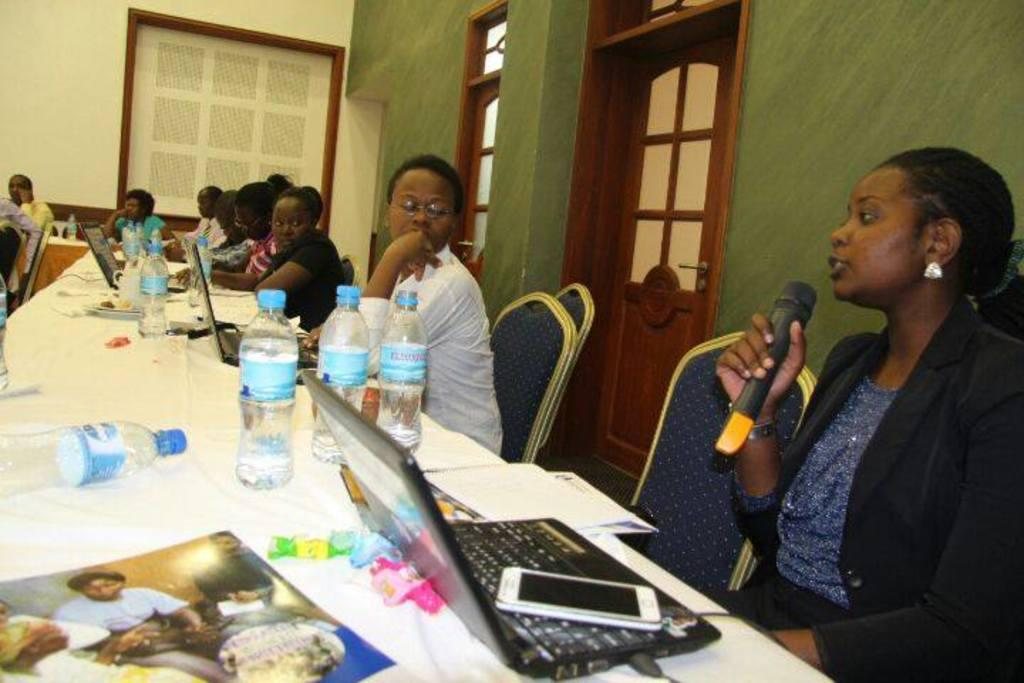How many people are in the room? There are people in the room, but the exact number is not specified. What are the people doing in the room? The people are sitting in front of chairs. What objects can be seen on the table in the room? There are bottles, laptops, and notes on the table. What are the possible ways to enter or exit the room? There is a door and a window in the room. Can you see a stream of water flowing through the room in the image? There is no stream of water visible in the image. What type of finger is shown holding a laptop in the image? There are no fingers holding a laptop in the image; only the laptops themselves are visible. 